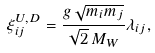Convert formula to latex. <formula><loc_0><loc_0><loc_500><loc_500>\xi ^ { U , D } _ { i j } = \frac { g \, \sqrt { m _ { i } m _ { j } } } { \sqrt { 2 } \, M _ { W } } \lambda _ { i j } ,</formula> 